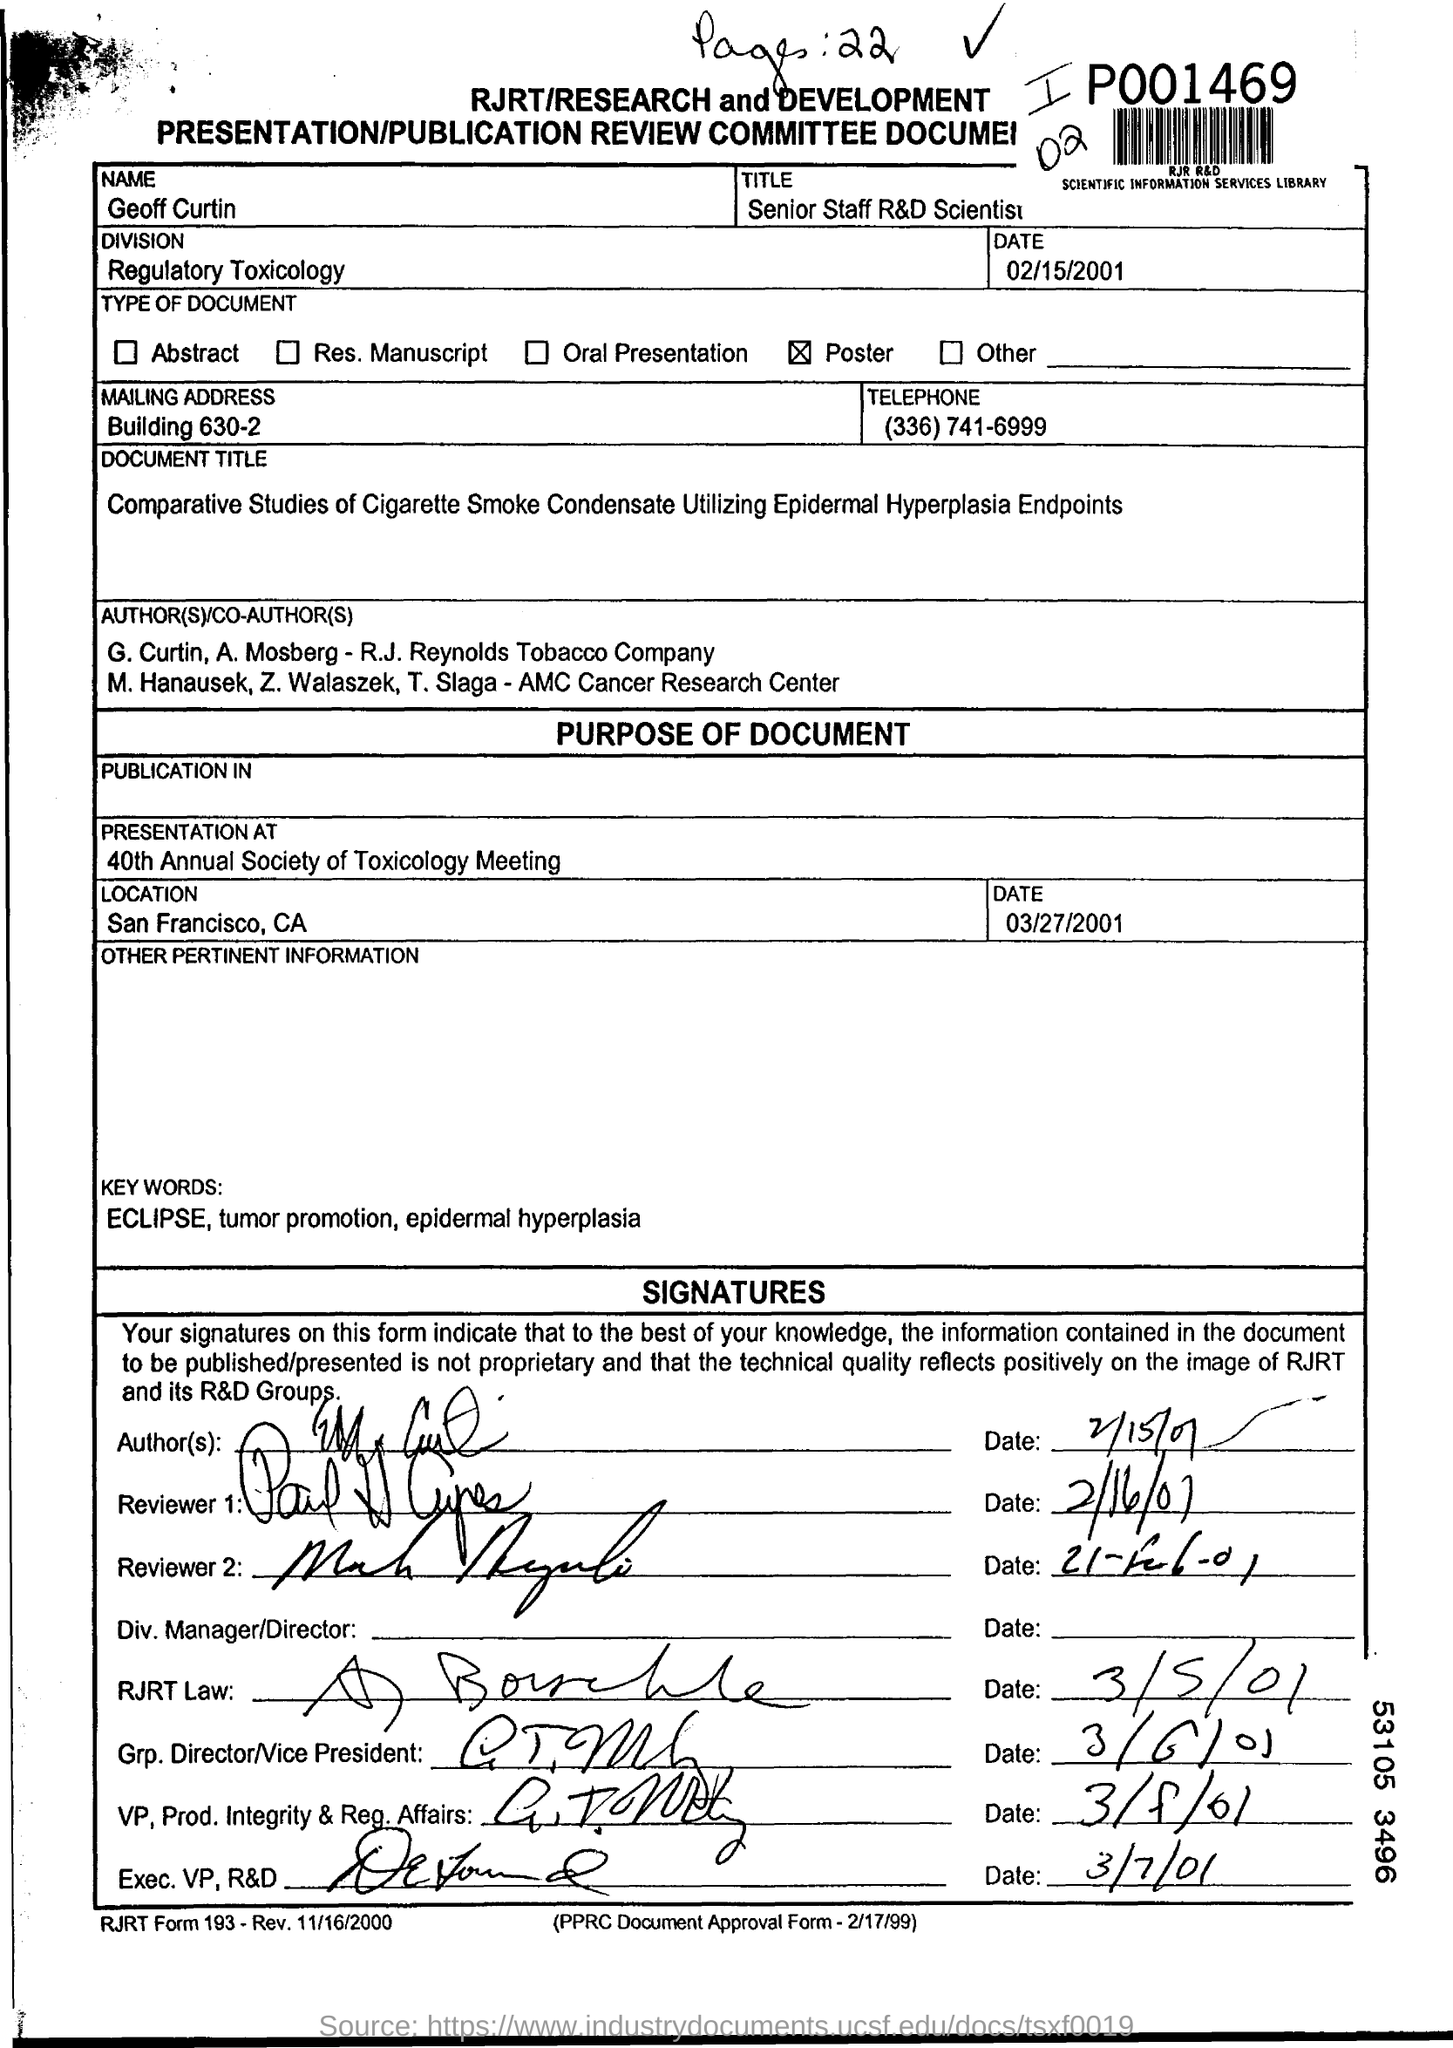Mention a couple of crucial points in this snapshot. The person mentioned in the form is named Geoff Curtin. The type of document is a poster. The presentation is taking place at the 40th Annual Society of Toxicology Meeting. The presentation is located in San Francisco, California. The division of Regulatory Toxicology is mentioned. 